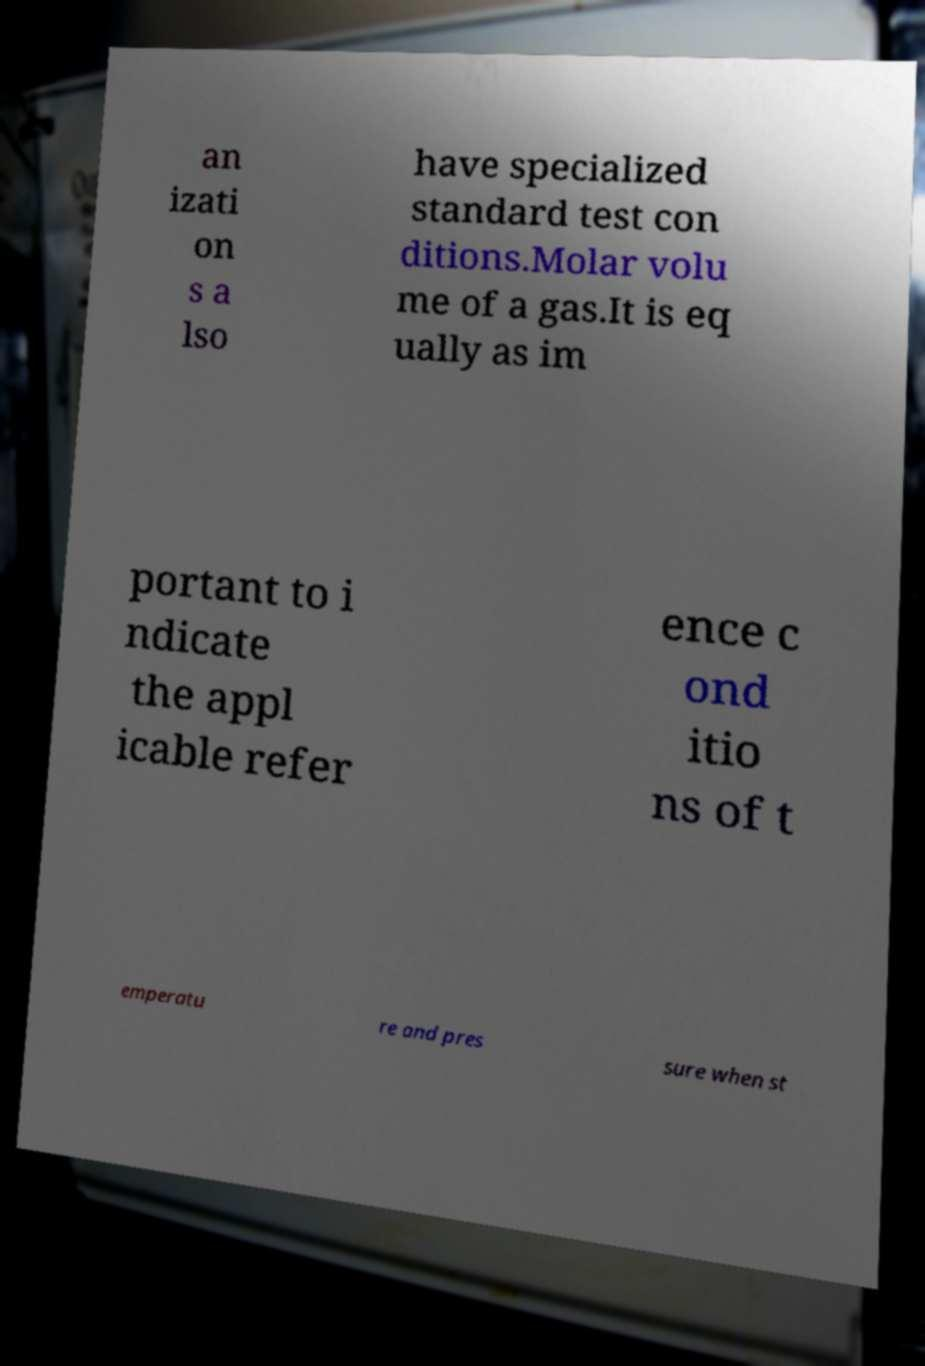For documentation purposes, I need the text within this image transcribed. Could you provide that? an izati on s a lso have specialized standard test con ditions.Molar volu me of a gas.It is eq ually as im portant to i ndicate the appl icable refer ence c ond itio ns of t emperatu re and pres sure when st 